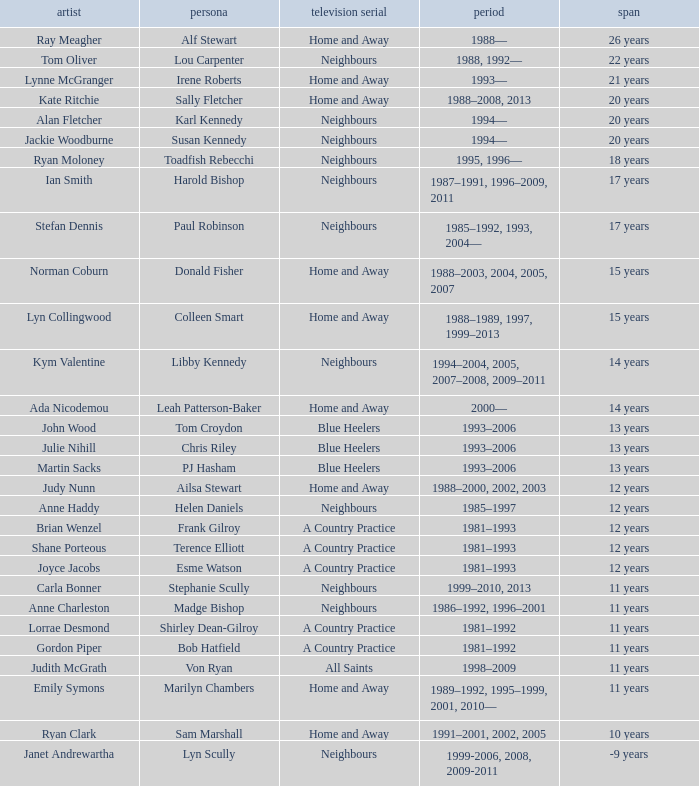What character was portrayed by the same actor for 12 years on Neighbours? Helen Daniels. 